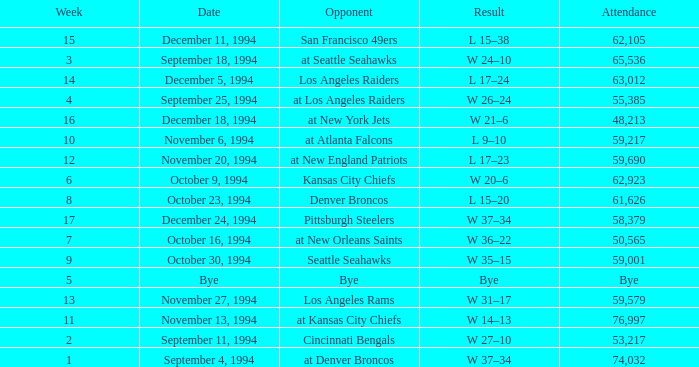In the game on or before week 9, who was the opponent when the attendance was 61,626? Denver Broncos. 